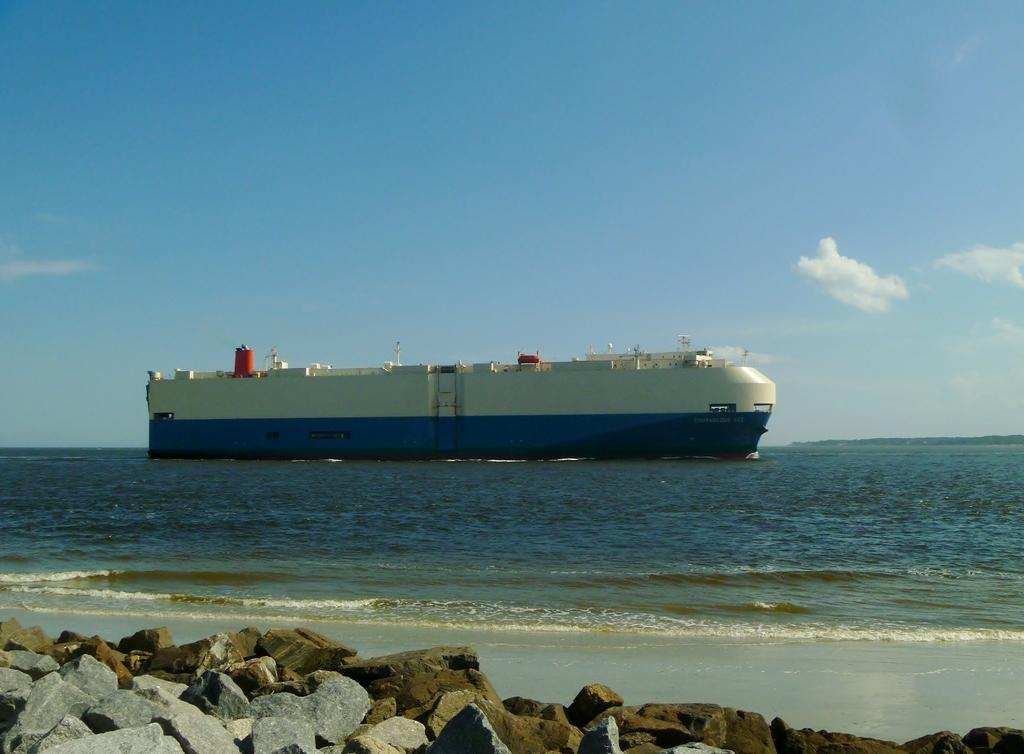What can be seen in the background of the image? The background of the image contains a clear blue sky with clouds. What is the main subject of the image? There is a ship in the image. What type of environment is depicted in the image? There is water visible in the image, suggesting a marine or coastal setting. What type of natural feature can be seen near the sea shore in the image? Stones are present near the sea shore in the image. What type of van can be seen parked near the ship in the image? There is no van present in the image; it only features a ship and a marine or coastal setting. How many stars can be seen in the sky in the image? The sky in the image is clear blue with clouds, so no stars are visible. 